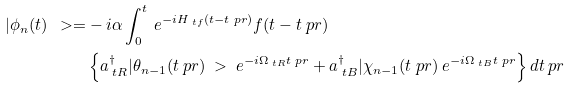<formula> <loc_0><loc_0><loc_500><loc_500>| \phi _ { n } ( t ) \ > = & - i \alpha \int _ { 0 } ^ { t } \ e ^ { - i H _ { \ t f } ( t - t \ p r ) } f ( t - t \ p r ) \\ & \left \{ a _ { \ t R } ^ { \dagger } | \theta _ { n - 1 } ( t \ p r ) \ > \ e ^ { - i \Omega _ { \ t R } t \ p r } + a _ { \ t B } ^ { \dagger } | \chi _ { n - 1 } ( t \ p r ) \ e ^ { - i \Omega _ { \ t B } t \ p r } \right \} d t \ p r</formula> 